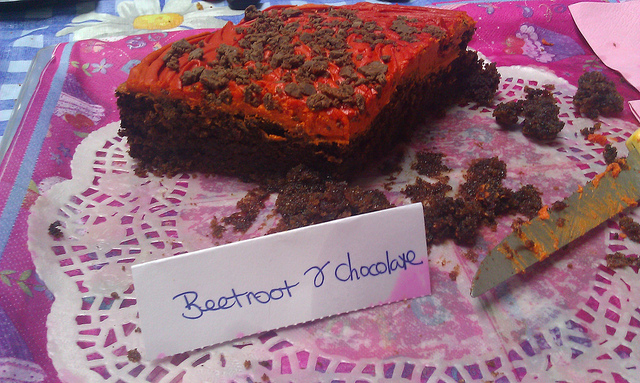Please transcribe the text information in this image. Beetroot r chocolate 